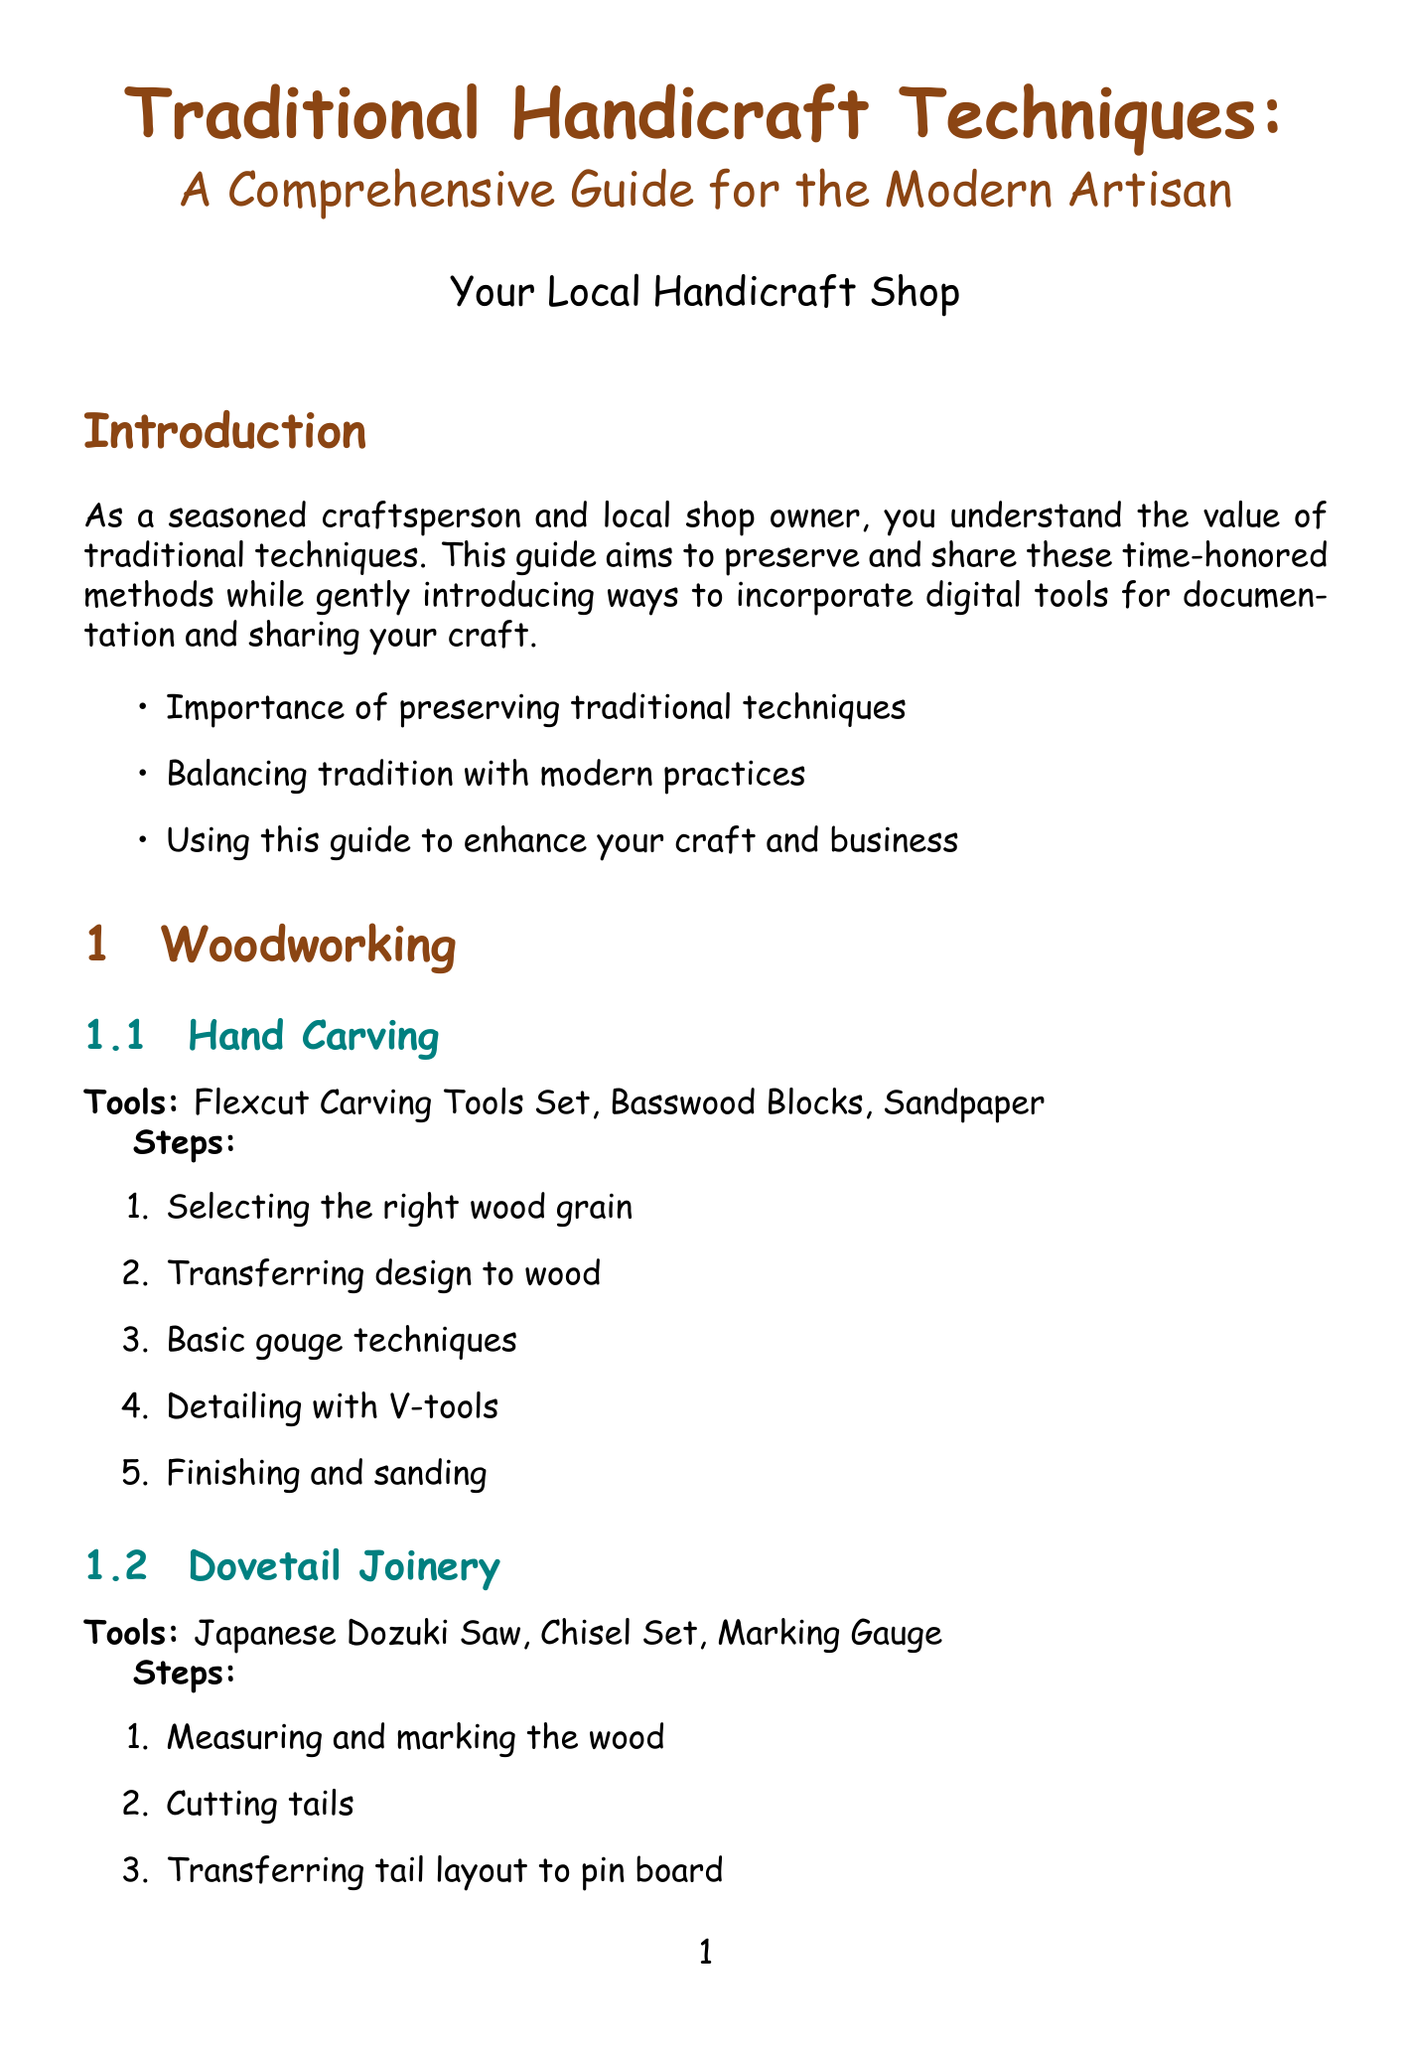What is the title of the guide? The title is explicitly mentioned at the top of the document as "Traditional Handicraft Techniques: A Comprehensive Guide for the Modern Artisan."
Answer: Traditional Handicraft Techniques: A Comprehensive Guide for the Modern Artisan How many main sections are in the document? The document contains four main sections: Woodworking, Textile Crafts, Pottery and Ceramics, and Metalworking.
Answer: 4 What is the first step in Hand Carving? The steps for Hand Carving are listed in a sequence, with the first step being "Selecting the right wood grain."
Answer: Selecting the right wood grain Which tool is needed for Sashiko Embroidery? The tools listed for Sashiko Embroidery include "Sashiko Needles," which are necessary for the technique.
Answer: Sashiko Needles How many techniques are listed under Pottery and Ceramics? There are two techniques listed under Pottery and Ceramics: Wheel Throwing and Coil Building.
Answer: 2 What is the purpose of the guide according to the introduction? The introduction outlines that the purpose of the guide is to "preserve and share these time-honored methods while gently introducing ways to incorporate digital tools."
Answer: Preserve and share traditional techniques What is the last tool mentioned in the Metalworking section? The last tool mentioned in the Metalworking section is "Gemstone Beads" used for Wire Wrapping Jewelry.
Answer: Gemstone Beads Name one resource listed in the appendix. The appendix includes resources such as "The Woolery - for textile crafts."
Answer: The Woolery - for textile crafts What is one of the final thoughts in the conclusion? One of the final thoughts mentioned in the conclusion is "Sharing your craft with the next generation."
Answer: Sharing your craft with the next generation 